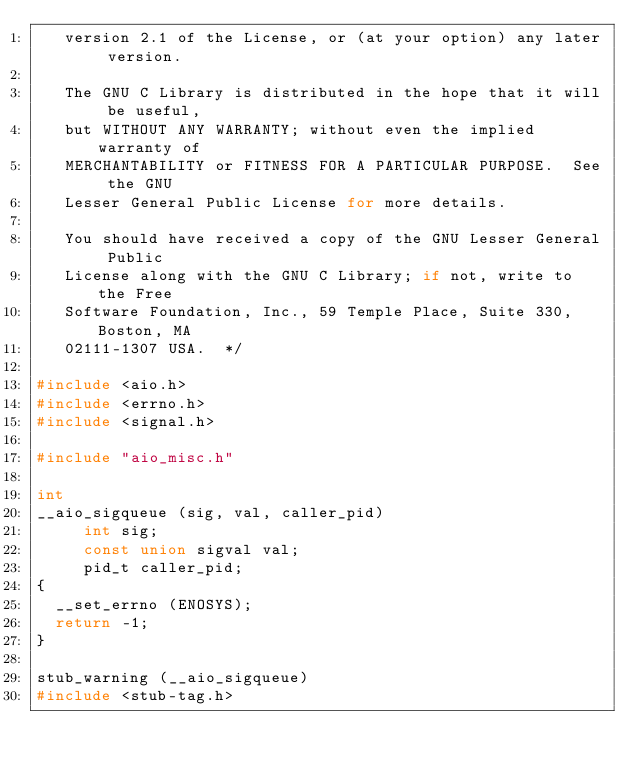Convert code to text. <code><loc_0><loc_0><loc_500><loc_500><_C_>   version 2.1 of the License, or (at your option) any later version.

   The GNU C Library is distributed in the hope that it will be useful,
   but WITHOUT ANY WARRANTY; without even the implied warranty of
   MERCHANTABILITY or FITNESS FOR A PARTICULAR PURPOSE.  See the GNU
   Lesser General Public License for more details.

   You should have received a copy of the GNU Lesser General Public
   License along with the GNU C Library; if not, write to the Free
   Software Foundation, Inc., 59 Temple Place, Suite 330, Boston, MA
   02111-1307 USA.  */

#include <aio.h>
#include <errno.h>
#include <signal.h>

#include "aio_misc.h"

int
__aio_sigqueue (sig, val, caller_pid)
     int sig;
     const union sigval val;
     pid_t caller_pid;
{
  __set_errno (ENOSYS);
  return -1;
}

stub_warning (__aio_sigqueue)
#include <stub-tag.h>
</code> 